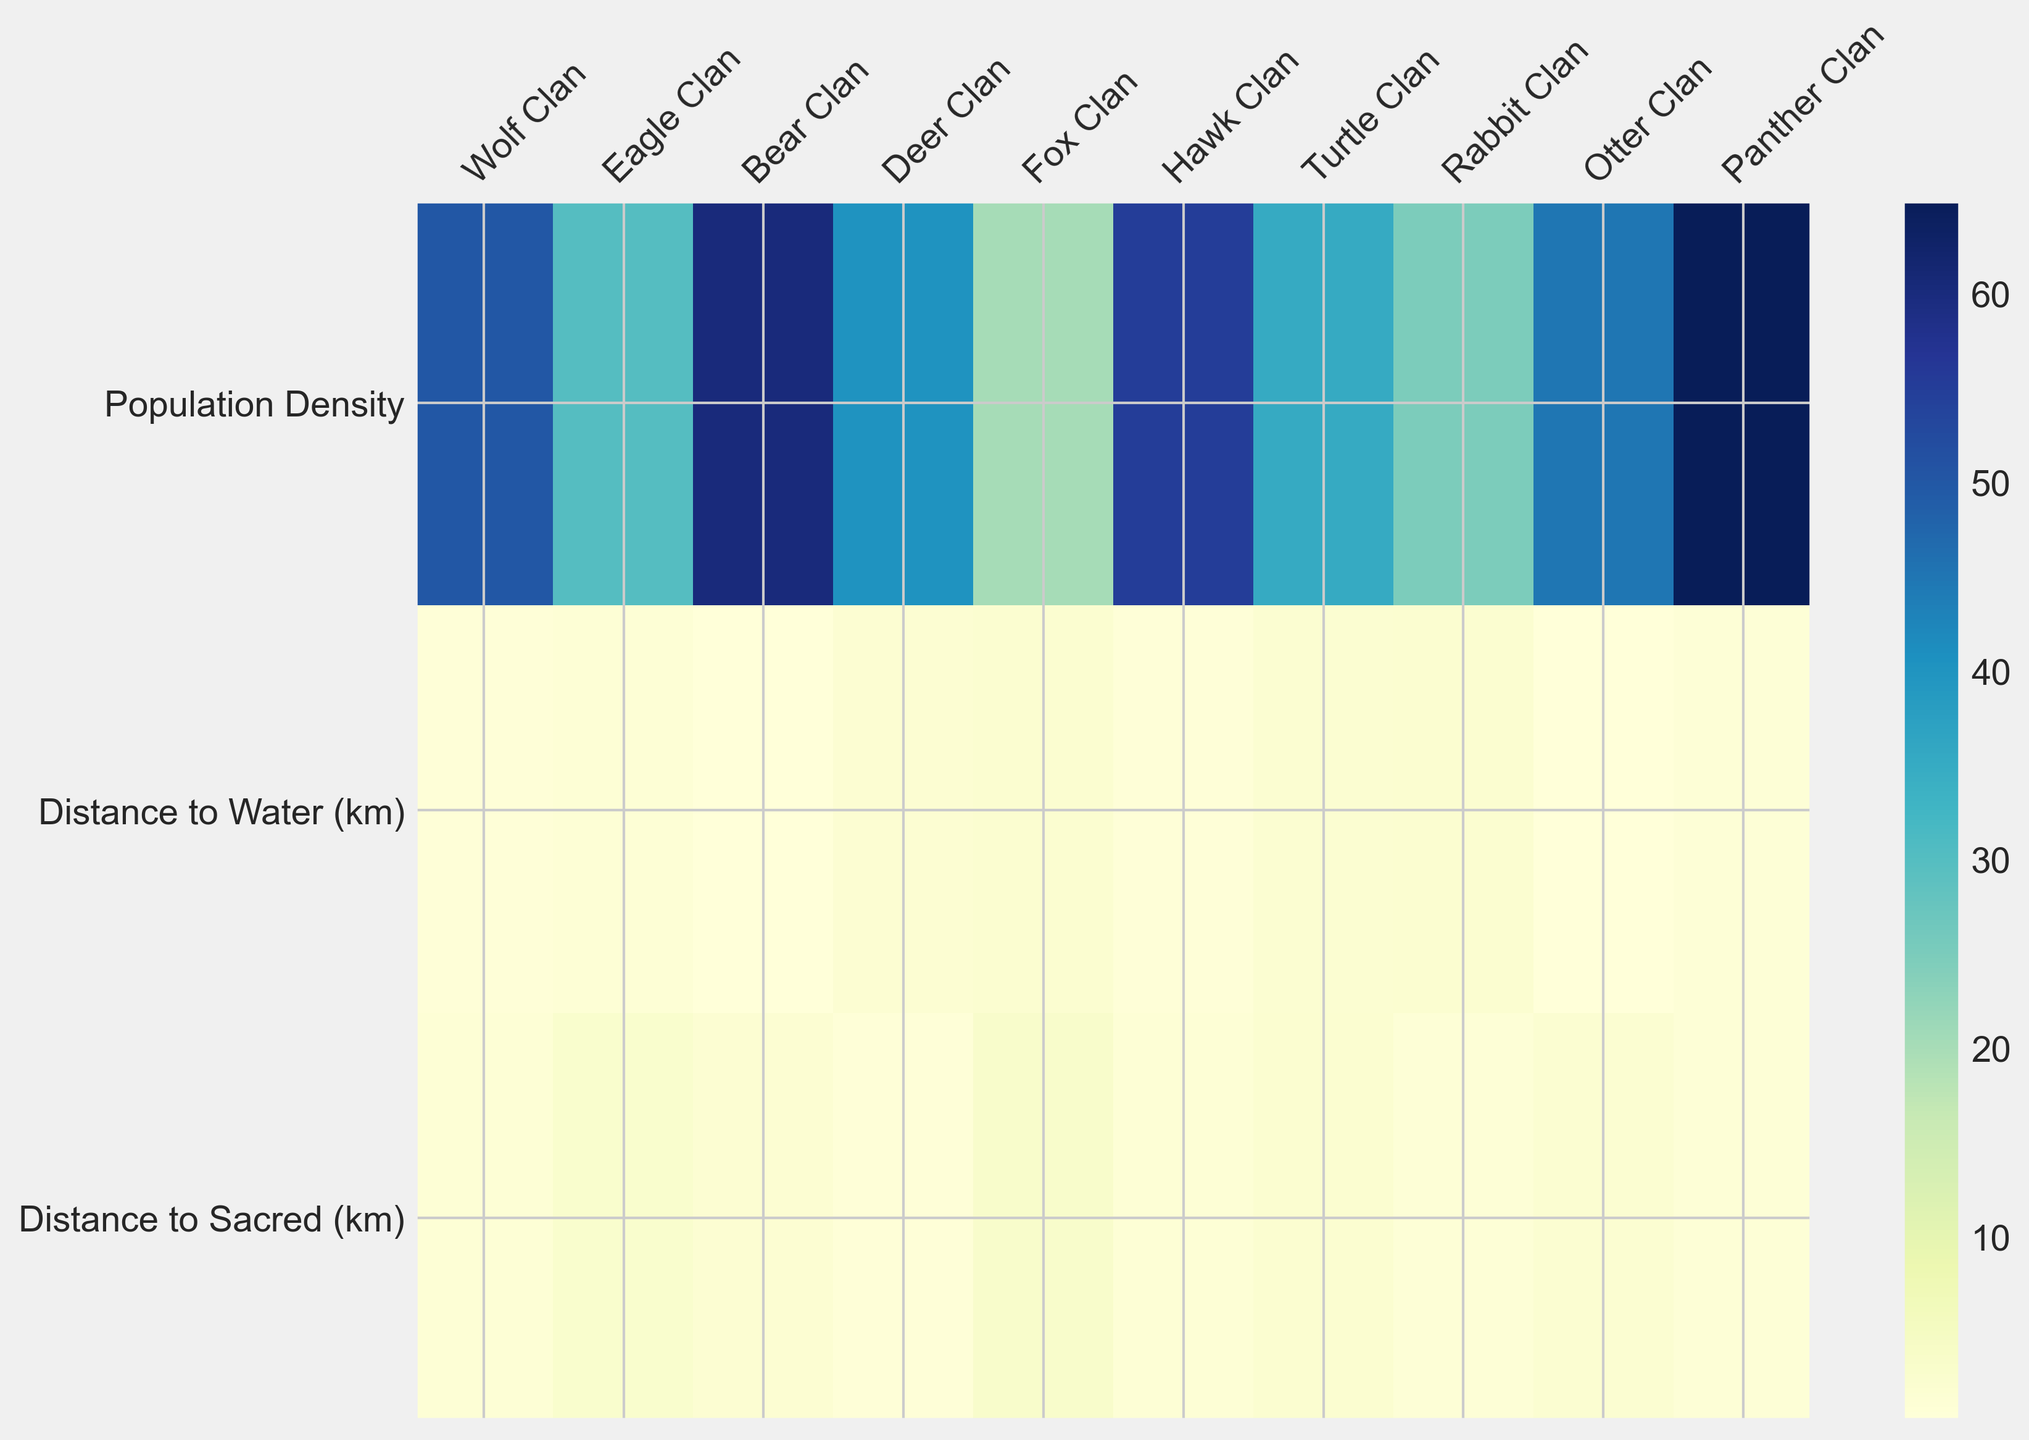Which clan has the highest population density? By examining the heatmap, look at the row labeled 'Population Density' and identify the column with the most intense color. The Panther Clan has the highest intensity, indicating the highest population density.
Answer: Panther Clan Which clan is closest to a natural water source? By checking the 'Distance to Water (km)' row and finding the column with the lowest value, represented by the lightest color, the Bear Clan appears closest to a natural water source.
Answer: Bear Clan Which clan is furthest from a sacred site? Observe the 'Distance to Sacred (km)' row and find the column with the darkest color, which corresponds to the highest value. The Fox Clan is furthest from a sacred site.
Answer: Fox Clan What is the average population density of the clans located within 1 km of a water source? Identify the clans within 1 km from 'Distance to Water (km)': Wolf, Bear, Hawk, and Otter Clans. Their population densities are 50, 60, 55, and 45. Calculate the average: (50+60+55+45)/4 = 52.5
Answer: 52.5 Compare the population density of the Eagle Clan and the Deer Clan. Which one is denser? Look at the 'Population Density' row and compare the columns for the Eagle Clan and Deer Clan. The Eagle Clan has a lower intensity than the Deer Clan.
Answer: Deer Clan Which clan has the highest combined distance to both water and the sacred site? Sum the values of the 'Distance to Water (km)' and 'Distance to Sacred (km)' rows for each clan. The Fox Clan has the highest combined distance (2.0 + 3.0 = 5.0).
Answer: Fox Clan Is the rabbit clan closer to a water source or a sacred site? Compare the colors in the 'Distance to Water (km)' and 'Distance to Sacred (km)' rows for the Rabbit Clan. The lighter color indicates a shorter distance. The sacred site's color is lighter.
Answer: Sacred Site What’s the difference in population density between the Turtle Clan and the Otter Clan? Locate the population densities for the Turtle Clan (35) and the Otter Clan (45), and calculate the difference: 45 - 35 = 10
Answer: 10 Rank the clans by their proximity to sacred sites, from closest to farthest. Identify the 'Distance to Sacred (km)' row, sort the colors from lightest to darkest, which correspond to smallest to largest values. The ranking is Deer, Panther, Rabbit, Wolf, Hawk, Bear, Otter, Eagle, Turtle, Fox.
Answer: Deer, Panther, Rabbit, Wolf, Hawk, Bear, Otter, Eagle, Turtle, Fox Which clan with a population density over 50 is closest to a water source? Filter the heatmap for population densities over 50: Bear, Hawk, and Panther Clans. Among them, the Bear Clan has the lightest color for 'Distance to Water (km)'.
Answer: Bear Clan 